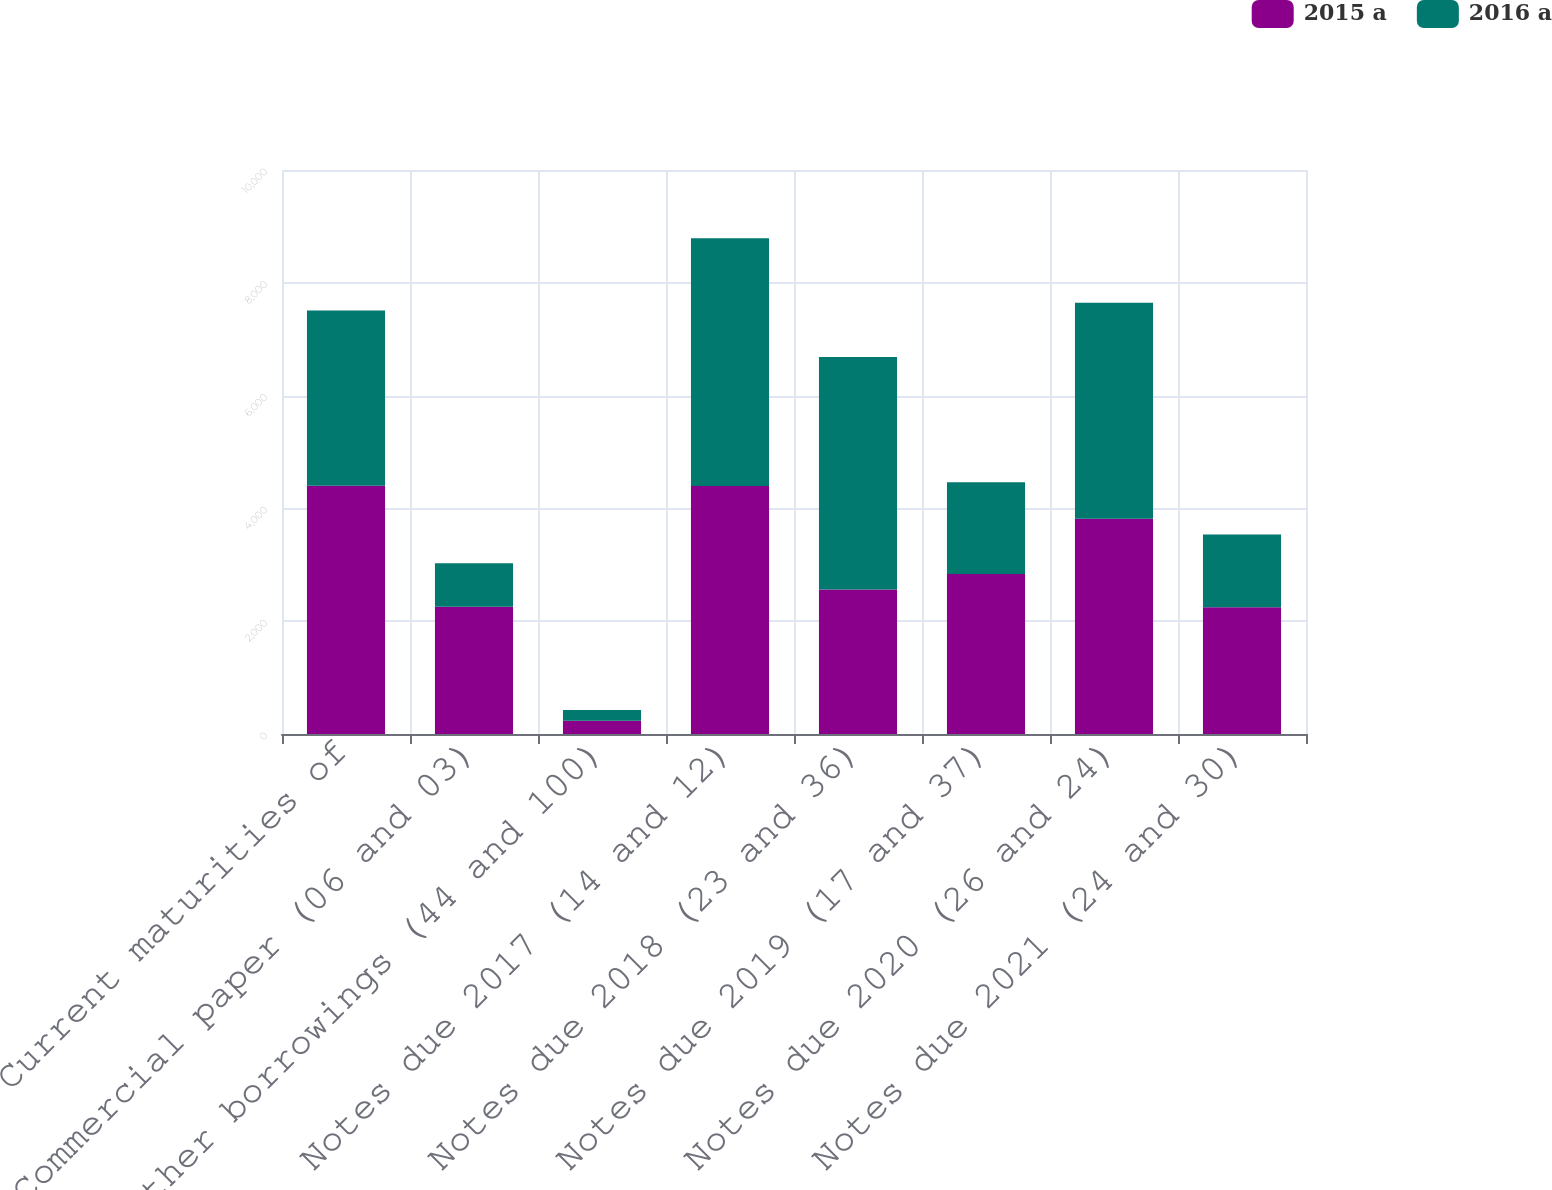Convert chart to OTSL. <chart><loc_0><loc_0><loc_500><loc_500><stacked_bar_chart><ecel><fcel>Current maturities of<fcel>Commercial paper (06 and 03)<fcel>Other borrowings (44 and 100)<fcel>Notes due 2017 (14 and 12)<fcel>Notes due 2018 (23 and 36)<fcel>Notes due 2019 (17 and 37)<fcel>Notes due 2020 (26 and 24)<fcel>Notes due 2021 (24 and 30)<nl><fcel>2015 a<fcel>4401<fcel>2257<fcel>234<fcel>4398<fcel>2561<fcel>2837<fcel>3816<fcel>2249<nl><fcel>2016 a<fcel>3109<fcel>770<fcel>192<fcel>4392<fcel>4122<fcel>1627<fcel>3830<fcel>1290<nl></chart> 